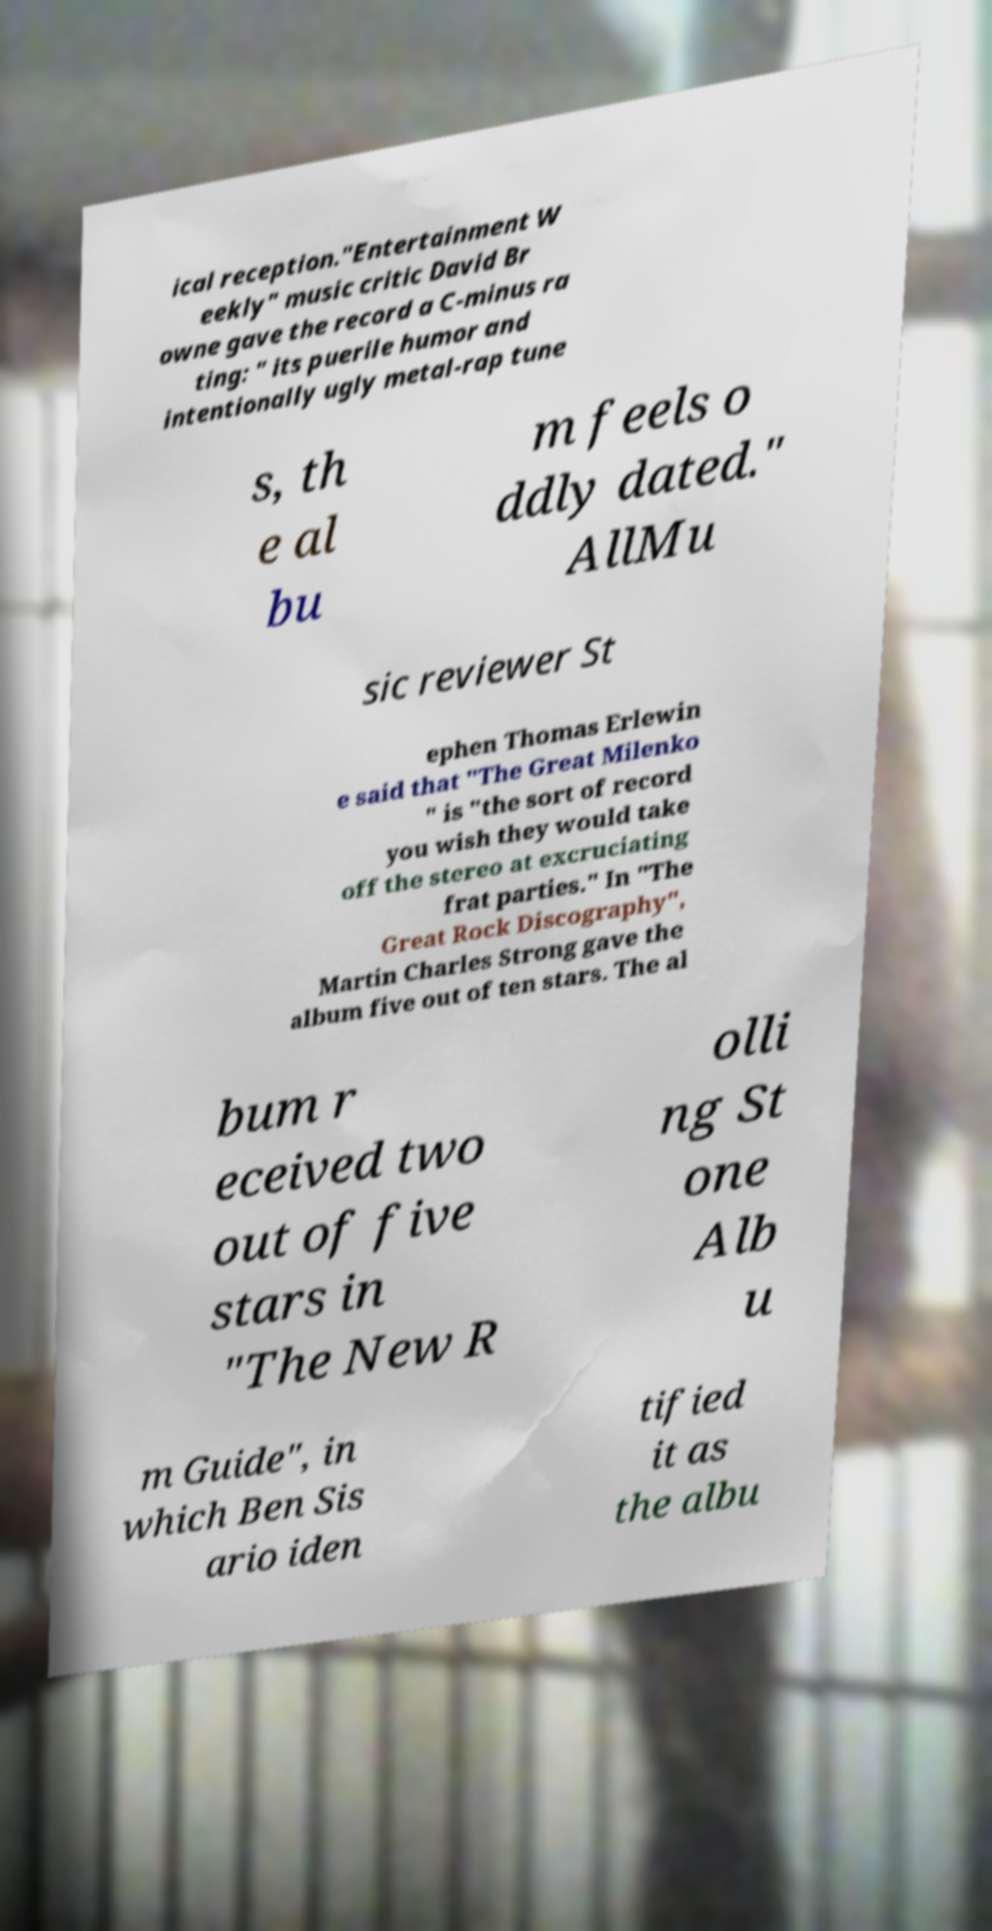Can you accurately transcribe the text from the provided image for me? ical reception."Entertainment W eekly" music critic David Br owne gave the record a C-minus ra ting: " its puerile humor and intentionally ugly metal-rap tune s, th e al bu m feels o ddly dated." AllMu sic reviewer St ephen Thomas Erlewin e said that "The Great Milenko " is "the sort of record you wish they would take off the stereo at excruciating frat parties." In "The Great Rock Discography", Martin Charles Strong gave the album five out of ten stars. The al bum r eceived two out of five stars in "The New R olli ng St one Alb u m Guide", in which Ben Sis ario iden tified it as the albu 